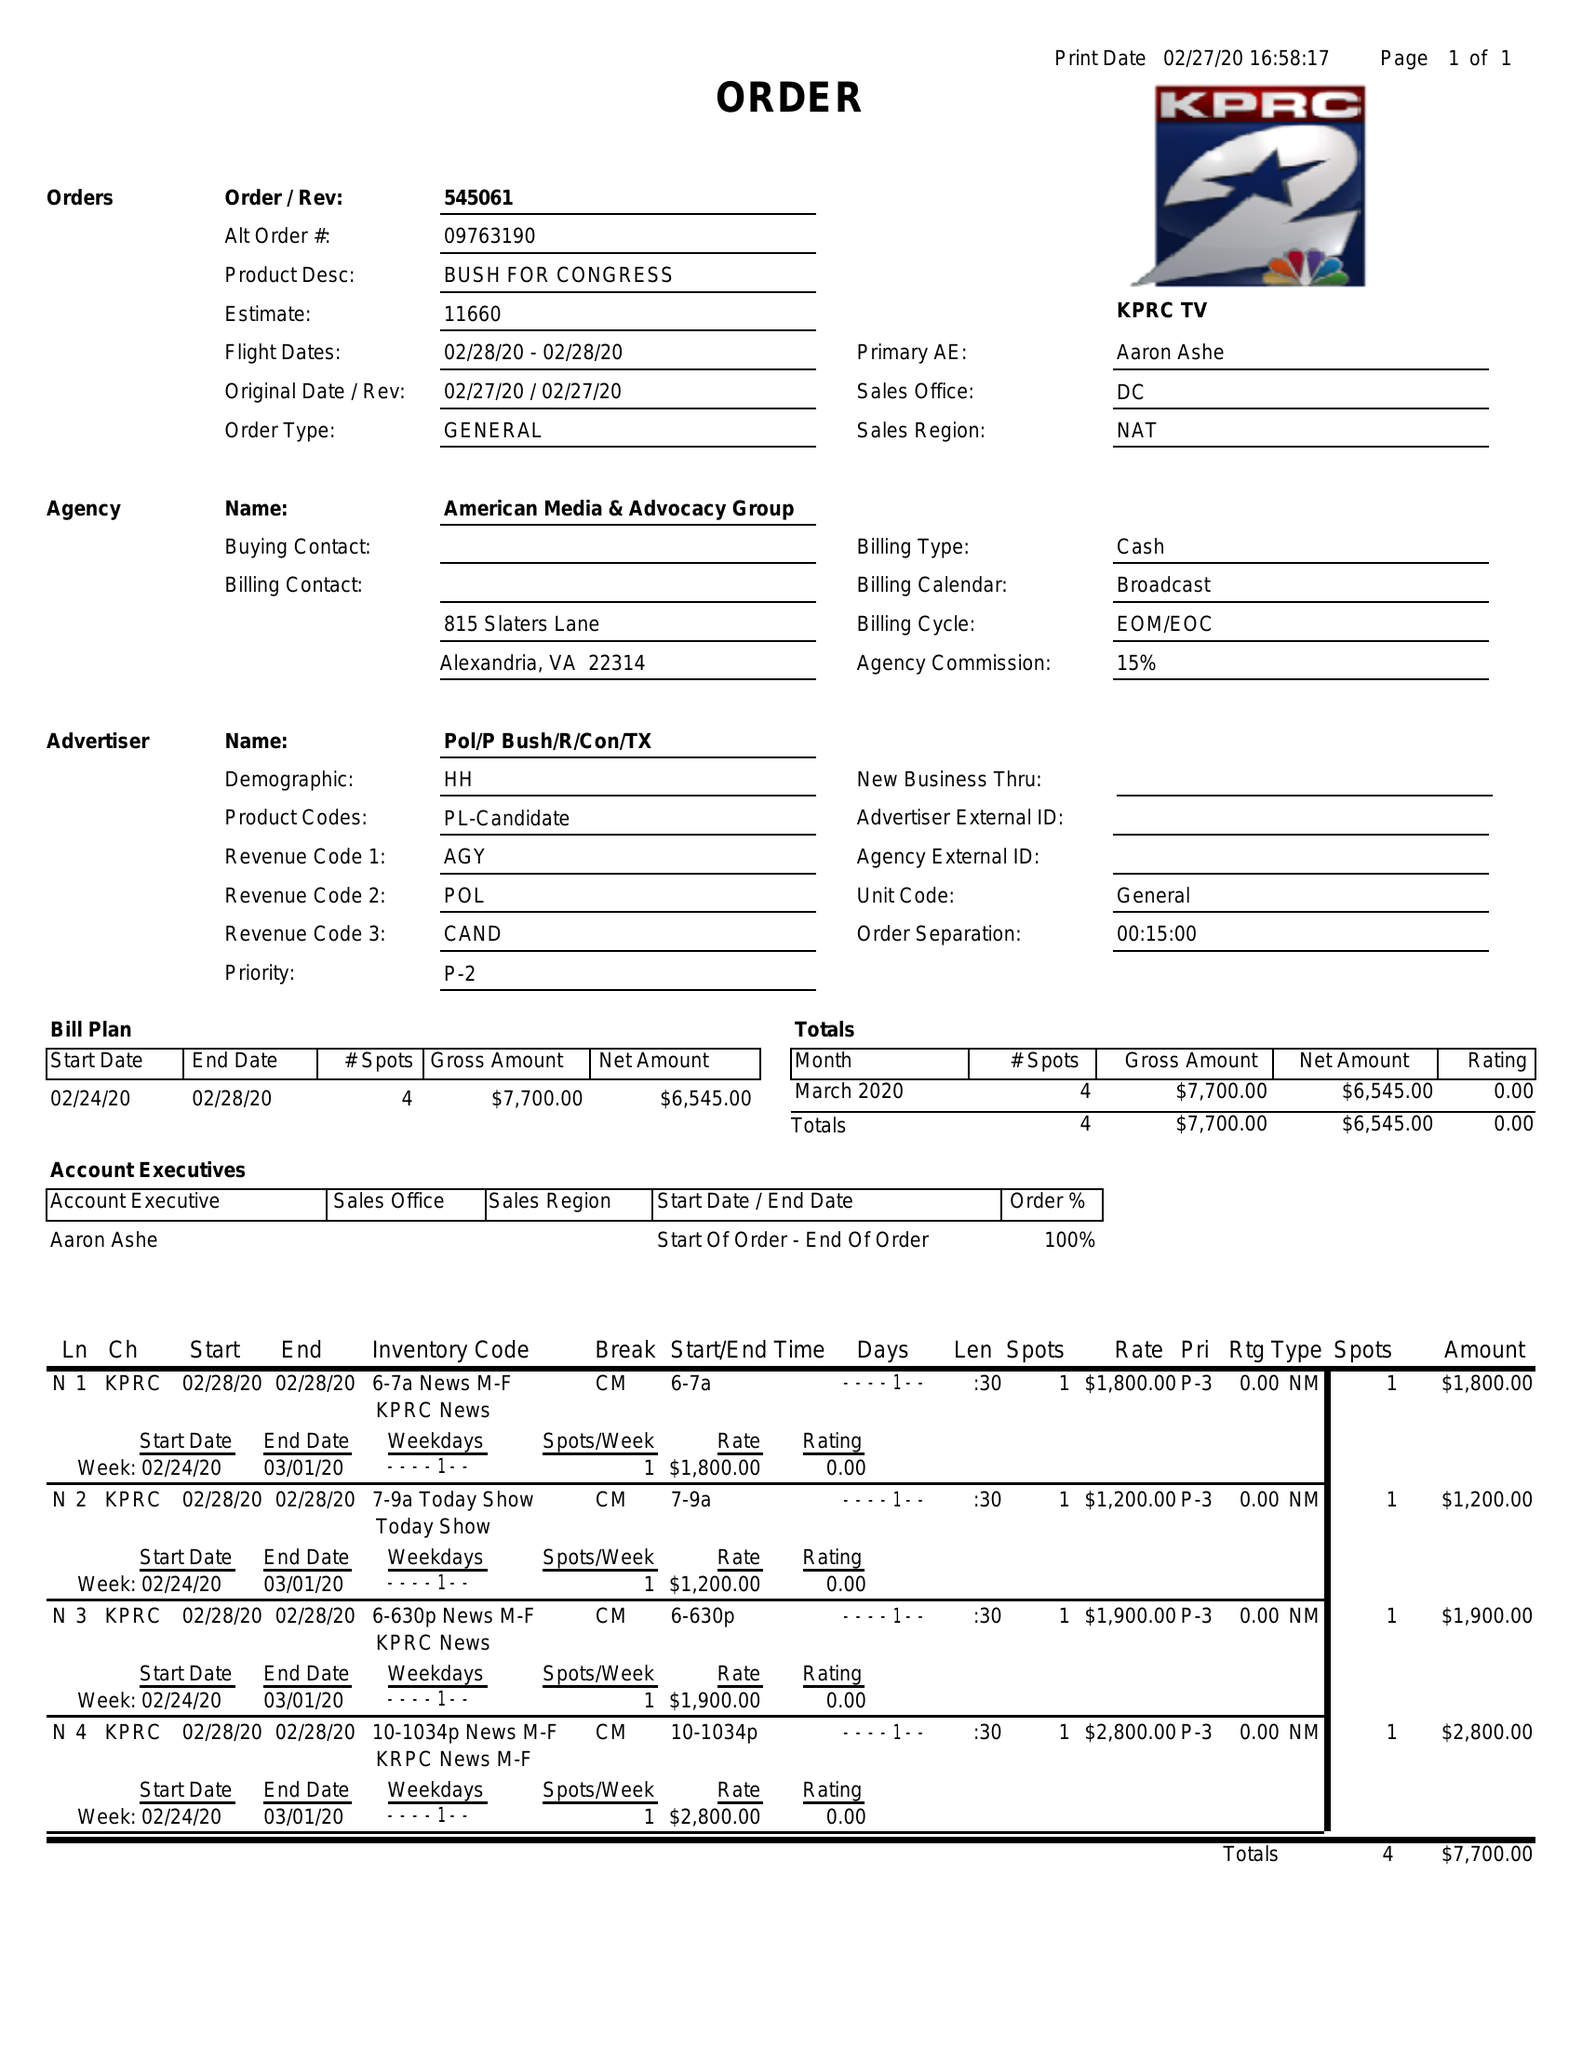What is the value for the contract_num?
Answer the question using a single word or phrase. 545061 